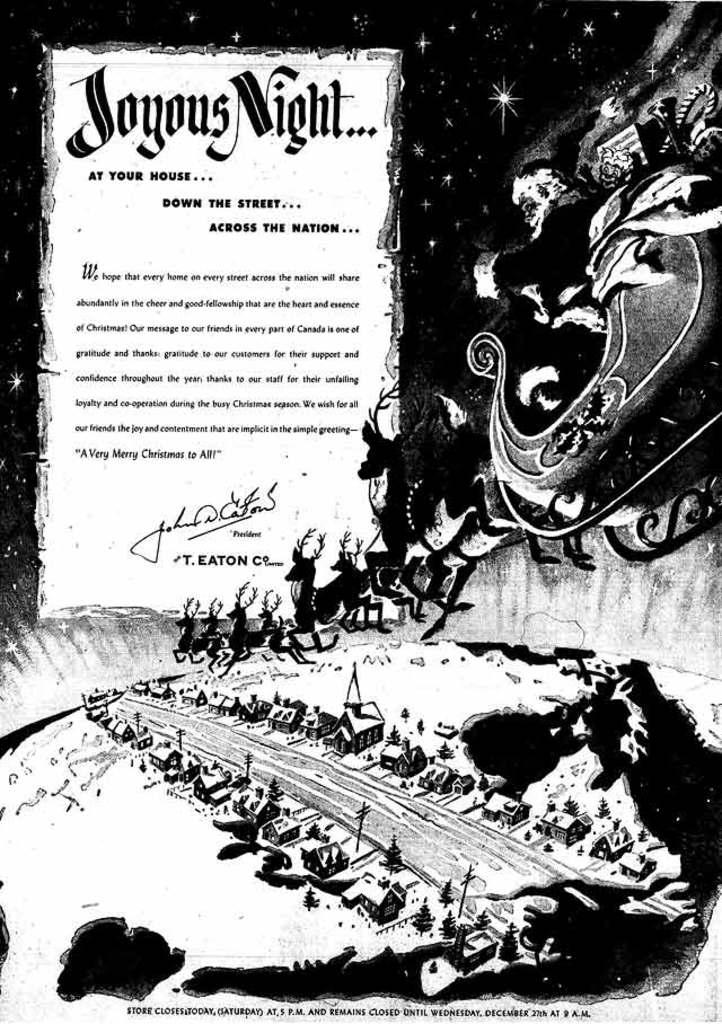<image>
Write a terse but informative summary of the picture. A black and white picture of a sled with a page that says Joyous Night 